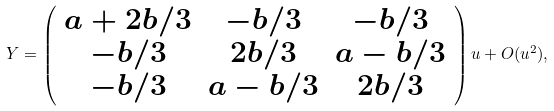Convert formula to latex. <formula><loc_0><loc_0><loc_500><loc_500>Y = \left ( \begin{array} { c c c } a + 2 b / 3 & - b / 3 & - b / 3 \\ - b / 3 & 2 b / 3 & a - b / 3 \\ - b / 3 & a - b / 3 & 2 b / 3 \end{array} \right ) u + O ( u ^ { 2 } ) ,</formula> 